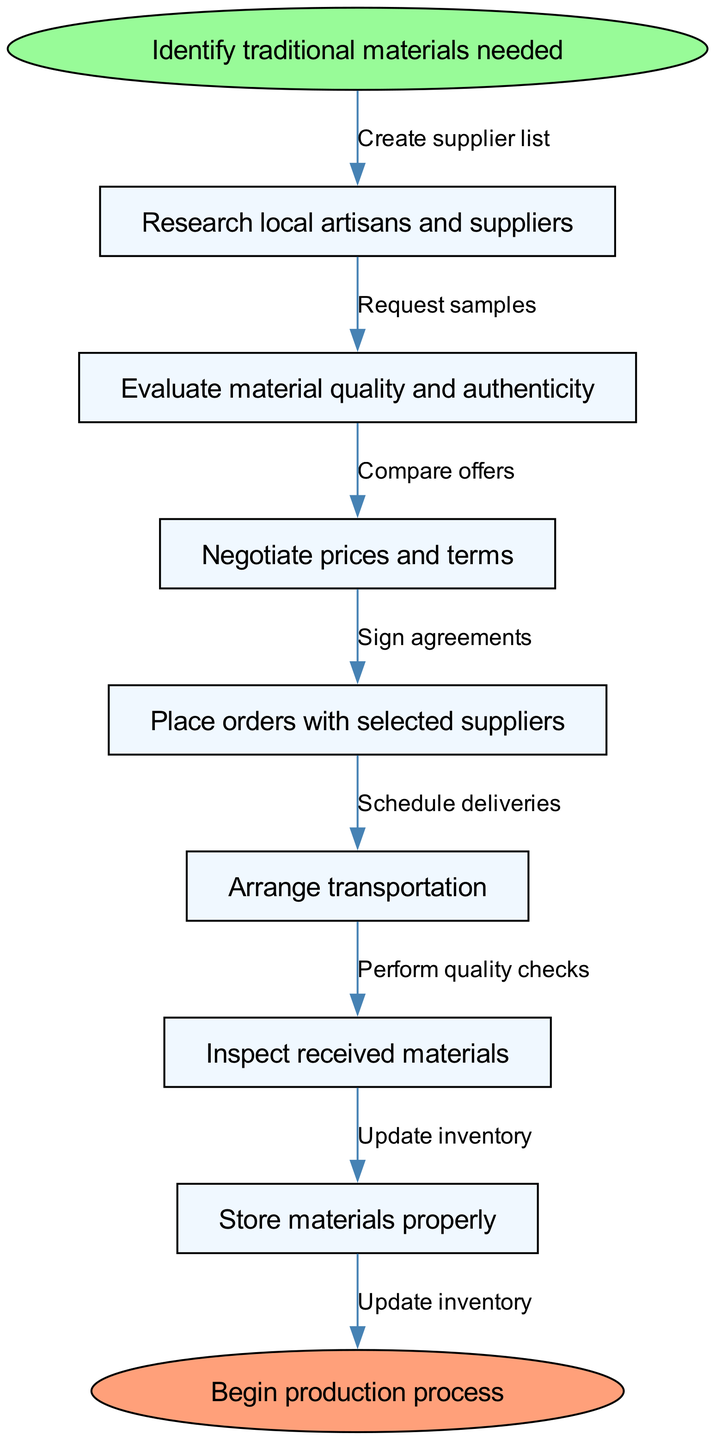What is the first step in the flow chart? The diagram starts with the node labeled "Identify traditional materials needed." This indicates that this is the initial action taken in the process of supply chain management.
Answer: Identify traditional materials needed How many nodes are in the flow chart? The diagram consists of a start node, six intermediate nodes (the steps), and an end node. Counting them all gives a total of eight nodes.
Answer: Eight What is the last action taken before beginning production? The final action before the end node, "Begin production process," is "Store materials properly." This indicates that storage is the last step in the sequence.
Answer: Store materials properly Which node follows "Evaluate material quality and authenticity"? According to the flow of the diagram, the next node after "Evaluate material quality and authenticity" is "Negotiate prices and terms." This shows the progression from evaluating to negotiating.
Answer: Negotiate prices and terms How many edges connect the nodes in the flow chart? The diagram has six edges connecting the intermediate nodes. This is calculated by observing that each of the six actions is linked by a directional edge to the next action.
Answer: Six Which two nodes are directly connected by the edge labeled "Request samples"? The edge labeled "Request samples" directly connects "Research local artisans and suppliers" to "Evaluate material quality and authenticity." This shows the progression from researching to evaluating.
Answer: Research local artisans and suppliers and Evaluate material quality and authenticity What is the purpose of the node "Inspect received materials"? The node "Inspect received materials" serves as a quality control step to ensure that the materials received from suppliers are up to standard before they are stored for production.
Answer: Quality control What type of edge follows the "Place orders with selected suppliers"? The edge that follows "Place orders with selected suppliers" is labeled "Sign agreements," indicating that after placing orders, formal agreements need to be signed with the suppliers.
Answer: Sign agreements What action is taken after "Negotiate prices and terms"? After "Negotiate prices and terms," the next action in the process is "Place orders with selected suppliers," indicating that negotiations lead to order placement.
Answer: Place orders with selected suppliers 